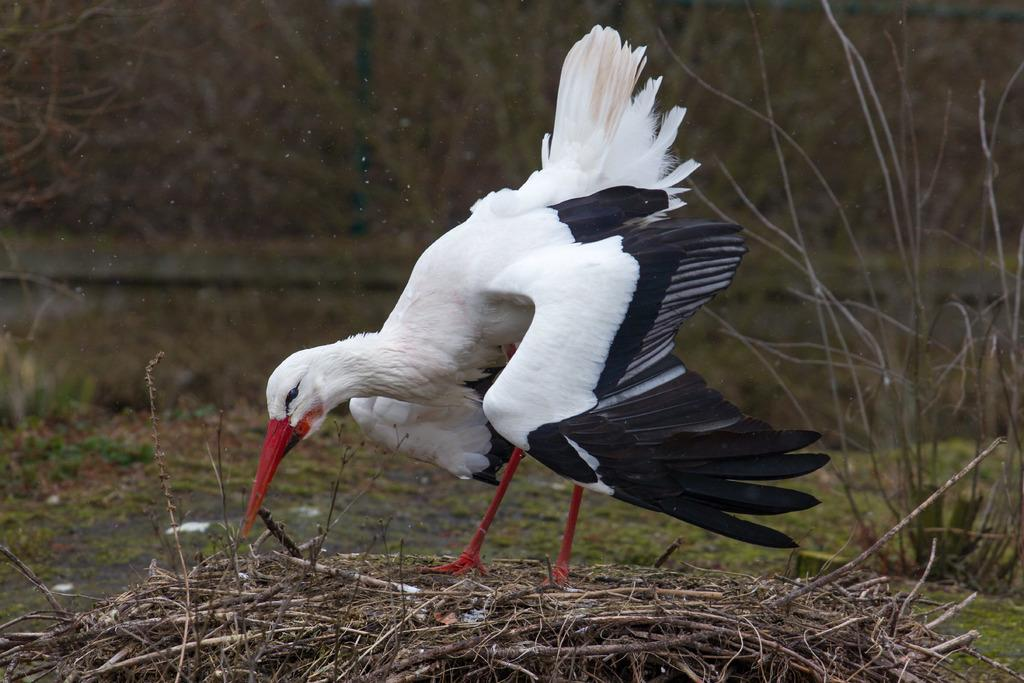What type of animal can be seen in the image? There is a bird in the image. What is the bird standing on? The bird is standing on dry sticks. What can be seen in the distance in the image? There are trees visible in the background of the image. What type of mark does the bird leave on the straw during its meal in the image? There is no straw or meal present in the image; the bird is standing on dry sticks. 